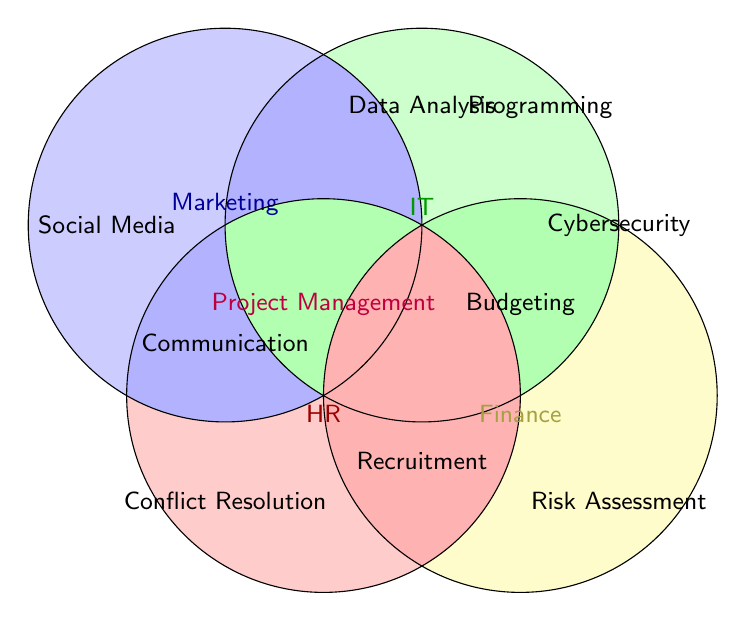What's the colored area of Marketing in the Venn Diagram? The blue shaded area represents the skills of Marketing.
Answer: Blue Which skill is shared by all four departments? The area where all four circles overlap has the text Project Management.
Answer: Project Management What is the intersection between Marketing and IT? The intersection (overlap) between the Marketing (blue) and IT (green) regions has the text Data Analysis.
Answer: Data Analysis How many unique skills are listed for the Finance department? Finance (yellow) has four skills listed: Data Analysis, Budgeting, Risk Assessment, and Project Management.
Answer: 4 Which skills are common between HR and IT but not any other department? The overlap between HR (red) and IT (green), excluding the common area with other departments, is not specifically depicted with a unique skill.
Answer: None Which department is associated with Social Media? The text Social Media is located within the circle labeled Marketing (blue).
Answer: Marketing Is Communication a skill shared by both Marketing and HR? The text Communication appears in the overlapping section of Marketing (blue) and HR (red).
Answer: Yes Which skill is shared between HR and Finance but not with Marketing? The overlap between HR (red) and Finance (yellow) does not explicitly depict a unique skill not shared with Marketing.
Answer: None 